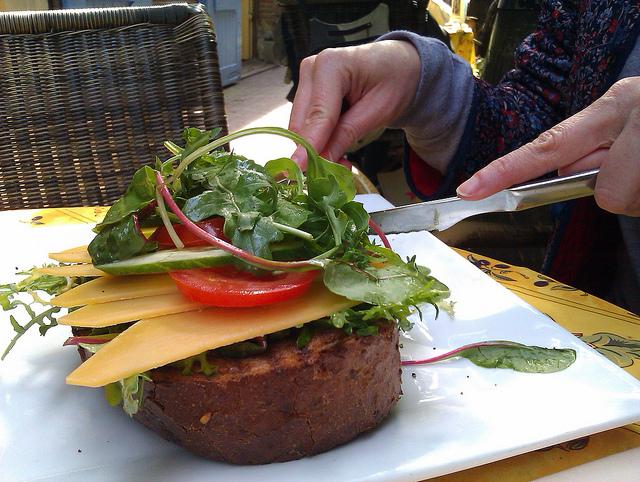What type of silverware is visible?
Be succinct. Knife. Does THIS PHOTO CONTAIN LETTUCE?
Be succinct. Yes. What are the vegetables and cheese on top of?
Quick response, please. Bread. 